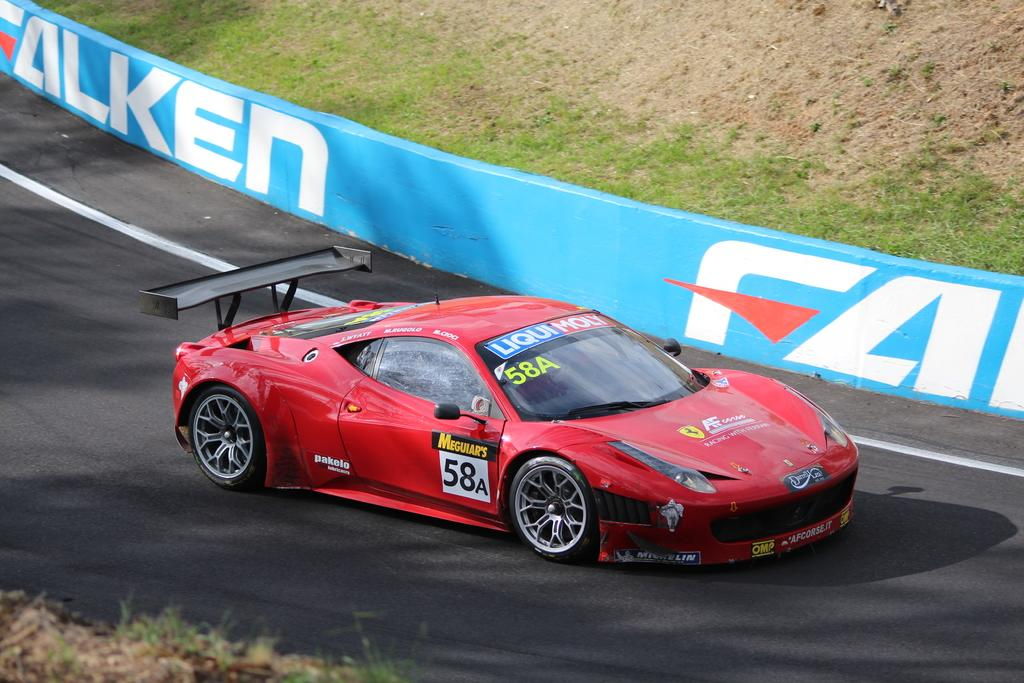What is the main subject of the image? The main subject of the image is a racing car. Where is the racing car located in the image? The racing car is on a track in the image. Can you tell me how many sheep are visible in the image? There are no sheep or wool present in the image; it features a racing car on a track. What type of writing can be seen on the racing car in the image? There is no writing visible on the racing car in the image. 